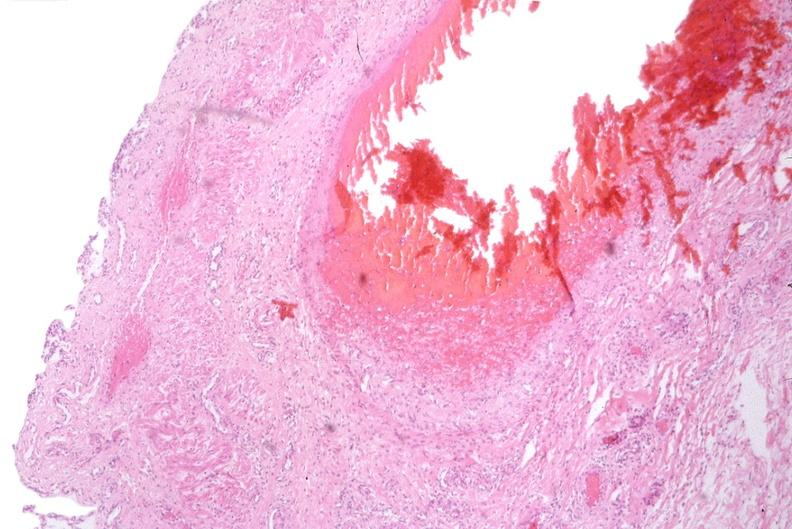why does this image show esophogus, varices?
Answer the question using a single word or phrase. Due to portal hypertension from cirrhosis hcv 